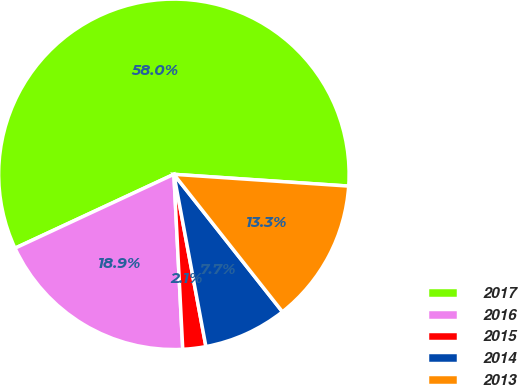Convert chart. <chart><loc_0><loc_0><loc_500><loc_500><pie_chart><fcel>2017<fcel>2016<fcel>2015<fcel>2014<fcel>2013<nl><fcel>58.0%<fcel>18.88%<fcel>2.12%<fcel>7.71%<fcel>13.29%<nl></chart> 